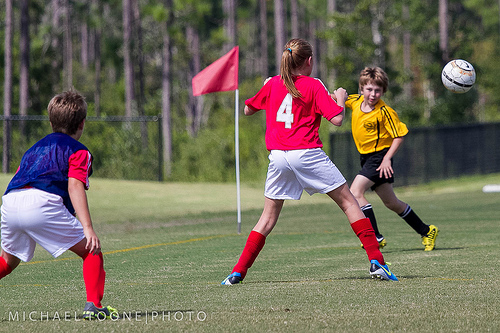<image>
Is there a tree behind the net? Yes. From this viewpoint, the tree is positioned behind the net, with the net partially or fully occluding the tree. 